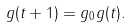Convert formula to latex. <formula><loc_0><loc_0><loc_500><loc_500>g ( t + 1 ) = g _ { 0 } g ( t ) .</formula> 